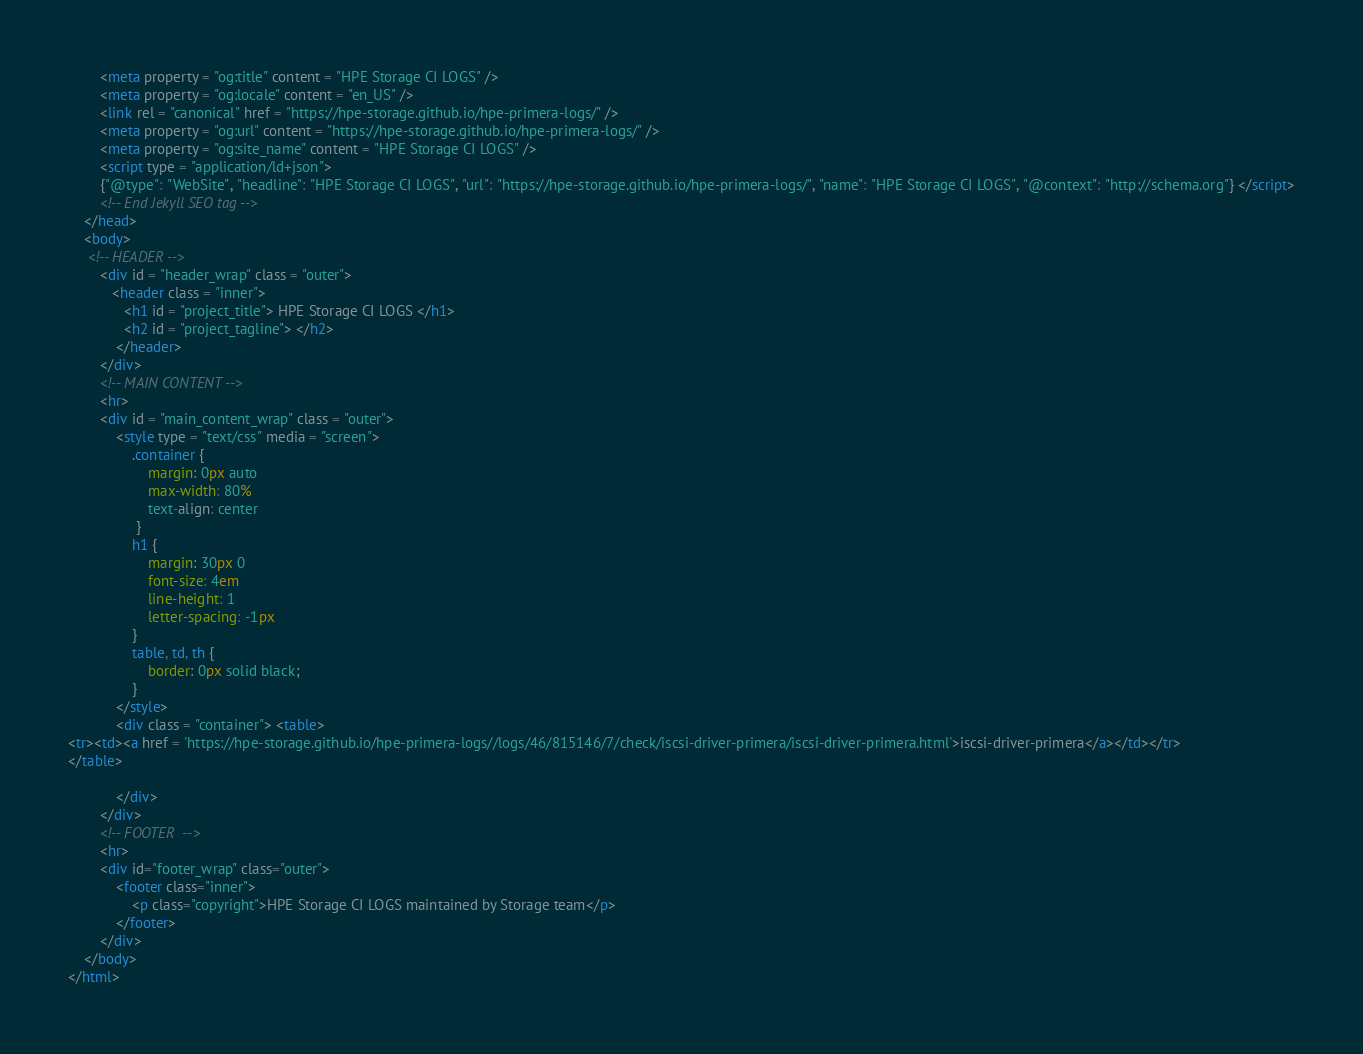<code> <loc_0><loc_0><loc_500><loc_500><_HTML_>        <meta property = "og:title" content = "HPE Storage CI LOGS" />
        <meta property = "og:locale" content = "en_US" />
        <link rel = "canonical" href = "https://hpe-storage.github.io/hpe-primera-logs/" />
        <meta property = "og:url" content = "https://hpe-storage.github.io/hpe-primera-logs/" />
        <meta property = "og:site_name" content = "HPE Storage CI LOGS" />
        <script type = "application/ld+json">
        {"@type": "WebSite", "headline": "HPE Storage CI LOGS", "url": "https://hpe-storage.github.io/hpe-primera-logs/", "name": "HPE Storage CI LOGS", "@context": "http://schema.org"} </script>
        <!-- End Jekyll SEO tag -->
    </head>
    <body>
     <!-- HEADER -->
        <div id = "header_wrap" class = "outer">
           <header class = "inner">
              <h1 id = "project_title"> HPE Storage CI LOGS </h1>
              <h2 id = "project_tagline"> </h2>
            </header>
        </div>
        <!-- MAIN CONTENT -->
        <hr>
        <div id = "main_content_wrap" class = "outer">
            <style type = "text/css" media = "screen">
                .container {
                    margin: 0px auto
                    max-width: 80%
                    text-align: center
                 }
                h1 {
                    margin: 30px 0
                    font-size: 4em
                    line-height: 1
                    letter-spacing: -1px
                }
                table, td, th {
                    border: 0px solid black;
                }
            </style>
            <div class = "container"> <table>
<tr><td><a href = 'https://hpe-storage.github.io/hpe-primera-logs//logs/46/815146/7/check/iscsi-driver-primera/iscsi-driver-primera.html'>iscsi-driver-primera</a></td></tr>
</table>

            </div>
        </div>
        <!-- FOOTER  -->
        <hr>
        <div id="footer_wrap" class="outer">
            <footer class="inner">
                <p class="copyright">HPE Storage CI LOGS maintained by Storage team</p>
            </footer>
        </div>
    </body>
</html>
</code> 